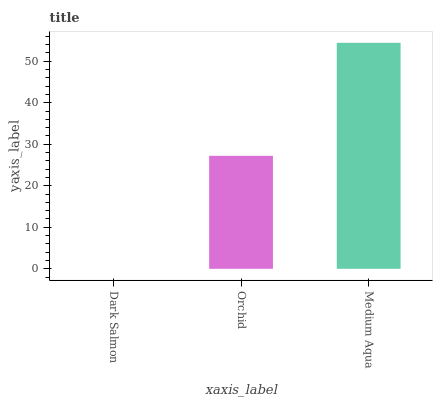Is Dark Salmon the minimum?
Answer yes or no. Yes. Is Medium Aqua the maximum?
Answer yes or no. Yes. Is Orchid the minimum?
Answer yes or no. No. Is Orchid the maximum?
Answer yes or no. No. Is Orchid greater than Dark Salmon?
Answer yes or no. Yes. Is Dark Salmon less than Orchid?
Answer yes or no. Yes. Is Dark Salmon greater than Orchid?
Answer yes or no. No. Is Orchid less than Dark Salmon?
Answer yes or no. No. Is Orchid the high median?
Answer yes or no. Yes. Is Orchid the low median?
Answer yes or no. Yes. Is Medium Aqua the high median?
Answer yes or no. No. Is Dark Salmon the low median?
Answer yes or no. No. 